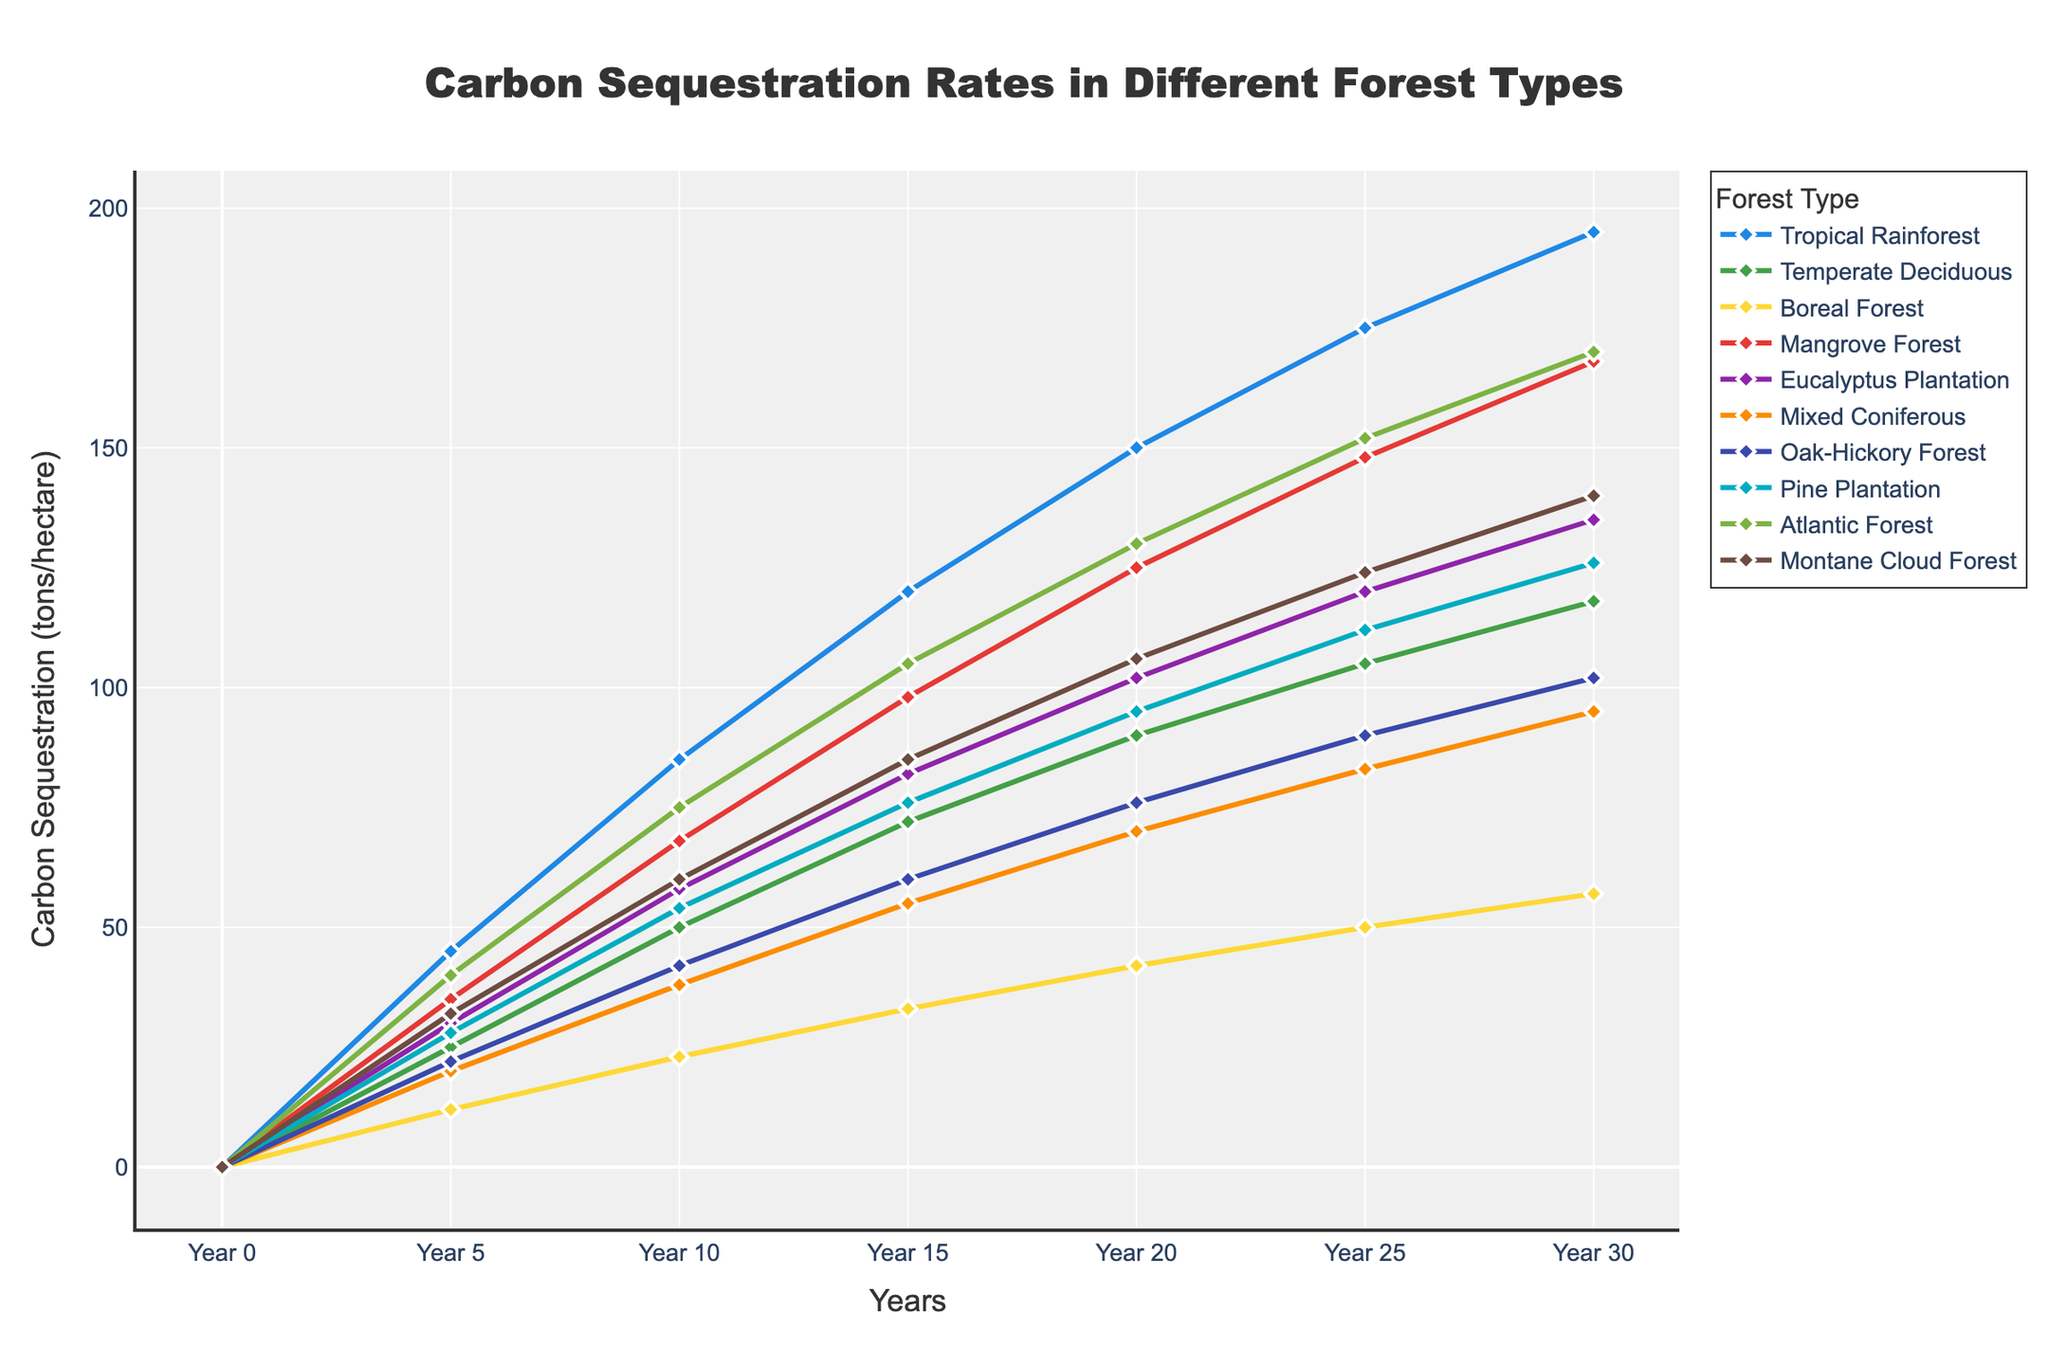What is the forest type with the highest carbon sequestration rate at Year 30? First, find Year 30 in the chart and look for the highest point among all forest types. The Tropical Rainforest has the highest value (195 tons/hectare).
Answer: Tropical Rainforest Which forest shows the steepest increase in carbon sequestration from Year 0 to Year 5? Look at the slopes of the lines between Year 0 and Year 5. The Tropical Rainforest increases from 0 to 45, which is the steepest rise.
Answer: Tropical Rainforest By how much does the carbon sequestration rate in the Mangrove Forest increase from Year 5 to Year 10? Find the values for the Mangrove Forest at Year 5 (35 tons/hectare) and Year 10 (68 tons/hectare) and then calculate the difference: 68 - 35.
Answer: 33 tons/hectare Is any forest type showing a linear growth in carbon sequestration over the 30 years? If so, which one? Visually inspect the lines to see if any have a consistent straight-line pattern. The Boreal Forest exhibits a nearly linear growth.
Answer: Boreal Forest Compare the carbon sequestration rate of the Eucalyptus Plantation and Pine Plantation at Year 25 and determine which is higher. Check the values at Year 25 for both forest types. Eucalyptus Plantation: 120 tons/hectare, Pine Plantation: 112 tons/hectare. Compare the two values.
Answer: Eucalyptus Plantation Does the Atlantic Forest sequester more carbon than the Montane Cloud Forest at Year 20? Find the Year 20 values for both forest types and compare. Atlantic Forest: 130 tons/hectare, Montane Cloud Forest: 106 tons/hectare.
Answer: Yes What is the average carbon sequestration rate of the Oak-Hickory Forest over the 30-year period? Sum the values of Oak-Hickory Forest at each year and then divide by the number of years. (0 + 22 + 42 + 60 + 76 + 90 + 102) / 7 = 392 / 7.
Answer: 56 tons/hectare Calculate the total carbon sequestered by the Mixed Coniferous and Temperate Deciduous forests at Year 30. Add the values for Mixed Coniferous (95 tons/hectare) and Temperate Deciduous (118 tons/hectare). 95 + 118.
Answer: 213 tons/hectare How much larger is the carbon sequestration rate of the Atlantic Forest compared to the Boreal Forest at Year 15? Find Year 15 values for Atlantic Forest (105 tons/hectare) and Boreal Forest (33 tons/hectare), then calculate the difference: 105 - 33.
Answer: 72 tons/hectare 